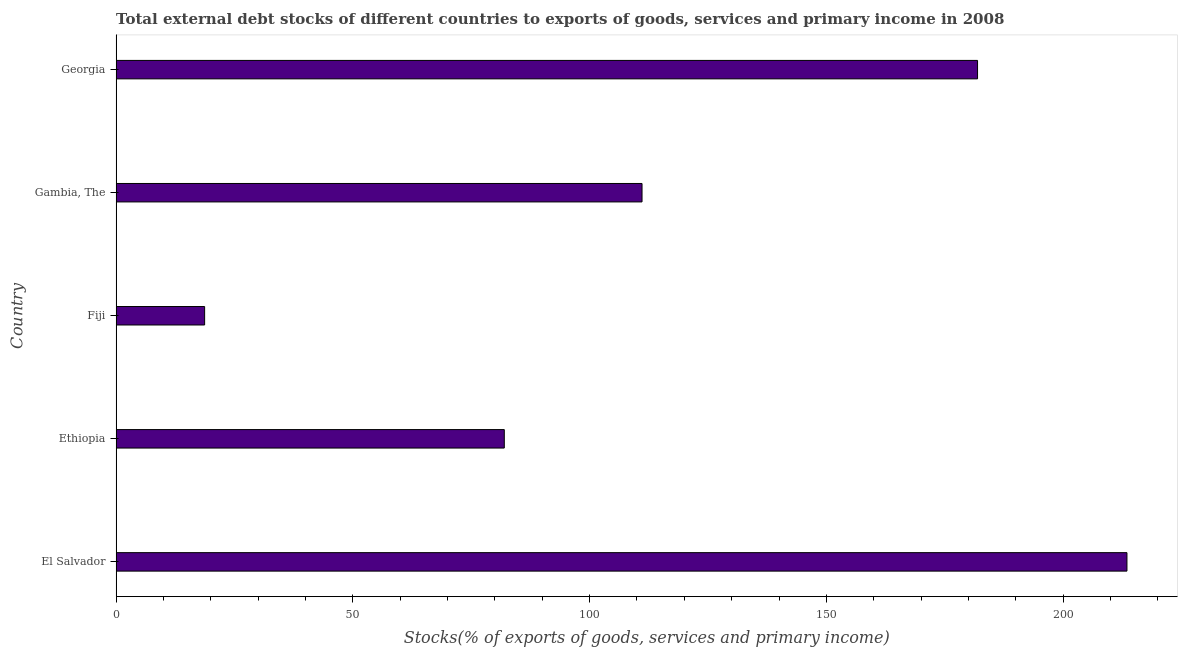Does the graph contain any zero values?
Your response must be concise. No. What is the title of the graph?
Make the answer very short. Total external debt stocks of different countries to exports of goods, services and primary income in 2008. What is the label or title of the X-axis?
Offer a very short reply. Stocks(% of exports of goods, services and primary income). What is the label or title of the Y-axis?
Keep it short and to the point. Country. What is the external debt stocks in Ethiopia?
Provide a short and direct response. 81.98. Across all countries, what is the maximum external debt stocks?
Give a very brief answer. 213.48. Across all countries, what is the minimum external debt stocks?
Provide a short and direct response. 18.69. In which country was the external debt stocks maximum?
Keep it short and to the point. El Salvador. In which country was the external debt stocks minimum?
Make the answer very short. Fiji. What is the sum of the external debt stocks?
Give a very brief answer. 607.15. What is the difference between the external debt stocks in Gambia, The and Georgia?
Provide a succinct answer. -70.86. What is the average external debt stocks per country?
Ensure brevity in your answer.  121.43. What is the median external debt stocks?
Offer a very short reply. 111.07. In how many countries, is the external debt stocks greater than 30 %?
Keep it short and to the point. 4. What is the ratio of the external debt stocks in Ethiopia to that in Gambia, The?
Keep it short and to the point. 0.74. Is the external debt stocks in El Salvador less than that in Georgia?
Offer a very short reply. No. Is the difference between the external debt stocks in Fiji and Gambia, The greater than the difference between any two countries?
Offer a very short reply. No. What is the difference between the highest and the second highest external debt stocks?
Offer a very short reply. 31.55. What is the difference between the highest and the lowest external debt stocks?
Your response must be concise. 194.79. In how many countries, is the external debt stocks greater than the average external debt stocks taken over all countries?
Your answer should be compact. 2. How many bars are there?
Keep it short and to the point. 5. How many countries are there in the graph?
Ensure brevity in your answer.  5. What is the difference between two consecutive major ticks on the X-axis?
Keep it short and to the point. 50. What is the Stocks(% of exports of goods, services and primary income) of El Salvador?
Provide a short and direct response. 213.48. What is the Stocks(% of exports of goods, services and primary income) in Ethiopia?
Provide a short and direct response. 81.98. What is the Stocks(% of exports of goods, services and primary income) of Fiji?
Your response must be concise. 18.69. What is the Stocks(% of exports of goods, services and primary income) of Gambia, The?
Keep it short and to the point. 111.07. What is the Stocks(% of exports of goods, services and primary income) in Georgia?
Ensure brevity in your answer.  181.93. What is the difference between the Stocks(% of exports of goods, services and primary income) in El Salvador and Ethiopia?
Your answer should be compact. 131.5. What is the difference between the Stocks(% of exports of goods, services and primary income) in El Salvador and Fiji?
Offer a terse response. 194.79. What is the difference between the Stocks(% of exports of goods, services and primary income) in El Salvador and Gambia, The?
Provide a short and direct response. 102.41. What is the difference between the Stocks(% of exports of goods, services and primary income) in El Salvador and Georgia?
Keep it short and to the point. 31.55. What is the difference between the Stocks(% of exports of goods, services and primary income) in Ethiopia and Fiji?
Make the answer very short. 63.29. What is the difference between the Stocks(% of exports of goods, services and primary income) in Ethiopia and Gambia, The?
Keep it short and to the point. -29.09. What is the difference between the Stocks(% of exports of goods, services and primary income) in Ethiopia and Georgia?
Offer a terse response. -99.95. What is the difference between the Stocks(% of exports of goods, services and primary income) in Fiji and Gambia, The?
Provide a succinct answer. -92.38. What is the difference between the Stocks(% of exports of goods, services and primary income) in Fiji and Georgia?
Your answer should be very brief. -163.24. What is the difference between the Stocks(% of exports of goods, services and primary income) in Gambia, The and Georgia?
Keep it short and to the point. -70.86. What is the ratio of the Stocks(% of exports of goods, services and primary income) in El Salvador to that in Ethiopia?
Your answer should be very brief. 2.6. What is the ratio of the Stocks(% of exports of goods, services and primary income) in El Salvador to that in Fiji?
Offer a very short reply. 11.42. What is the ratio of the Stocks(% of exports of goods, services and primary income) in El Salvador to that in Gambia, The?
Offer a very short reply. 1.92. What is the ratio of the Stocks(% of exports of goods, services and primary income) in El Salvador to that in Georgia?
Offer a terse response. 1.17. What is the ratio of the Stocks(% of exports of goods, services and primary income) in Ethiopia to that in Fiji?
Your answer should be compact. 4.39. What is the ratio of the Stocks(% of exports of goods, services and primary income) in Ethiopia to that in Gambia, The?
Offer a terse response. 0.74. What is the ratio of the Stocks(% of exports of goods, services and primary income) in Ethiopia to that in Georgia?
Keep it short and to the point. 0.45. What is the ratio of the Stocks(% of exports of goods, services and primary income) in Fiji to that in Gambia, The?
Ensure brevity in your answer.  0.17. What is the ratio of the Stocks(% of exports of goods, services and primary income) in Fiji to that in Georgia?
Keep it short and to the point. 0.1. What is the ratio of the Stocks(% of exports of goods, services and primary income) in Gambia, The to that in Georgia?
Keep it short and to the point. 0.61. 